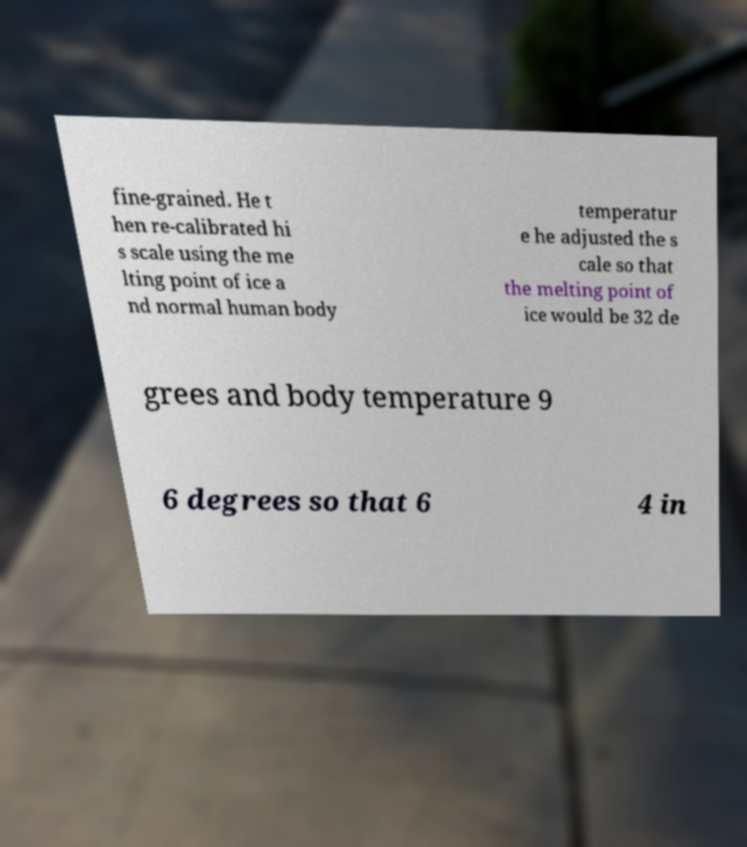For documentation purposes, I need the text within this image transcribed. Could you provide that? fine-grained. He t hen re-calibrated hi s scale using the me lting point of ice a nd normal human body temperatur e he adjusted the s cale so that the melting point of ice would be 32 de grees and body temperature 9 6 degrees so that 6 4 in 